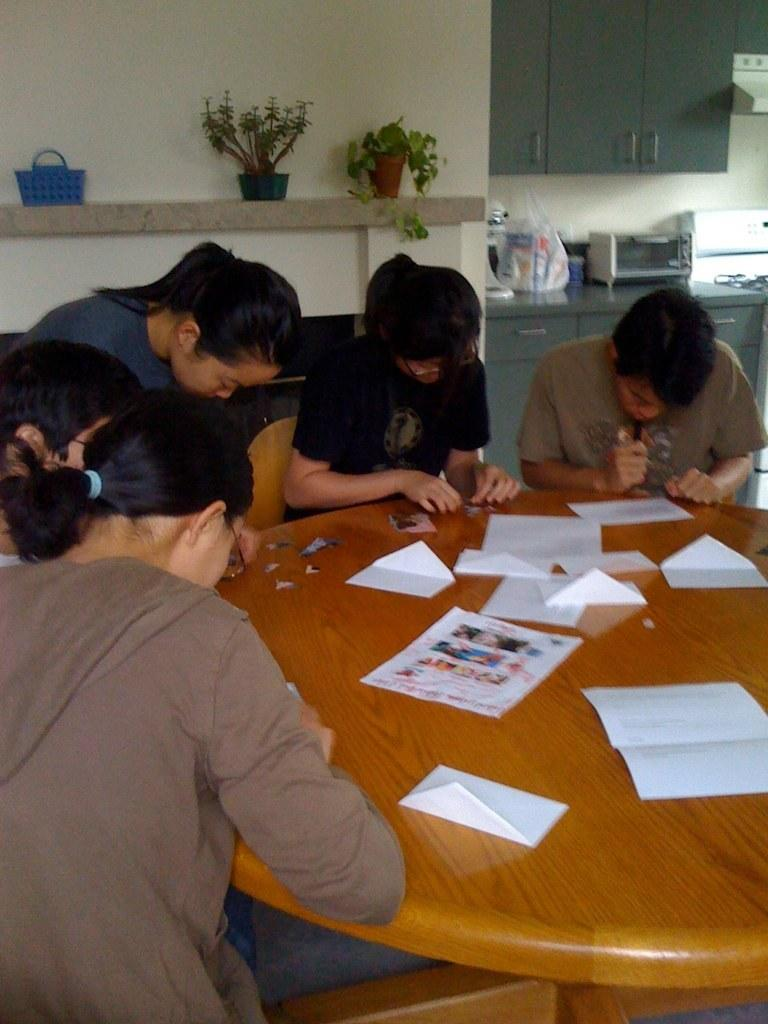How many people are in the image? There is a group of people in the image, but the exact number is not specified. What are the people doing in the image? The people are sitting around tables and doing paperwork. What type of furniture are the people using to sit on? The people are sitting on chairs. What can be seen in the background of the image? There are plants and a basket in the background of the image. Can you tell me how many pages the people are swimming through in the image? There is no swimming or pages present in the image; the people are doing paperwork while sitting on chairs. Are there any cherries visible in the image? There is no mention of cherries in the provided facts, so we cannot determine if they are present in the image. 